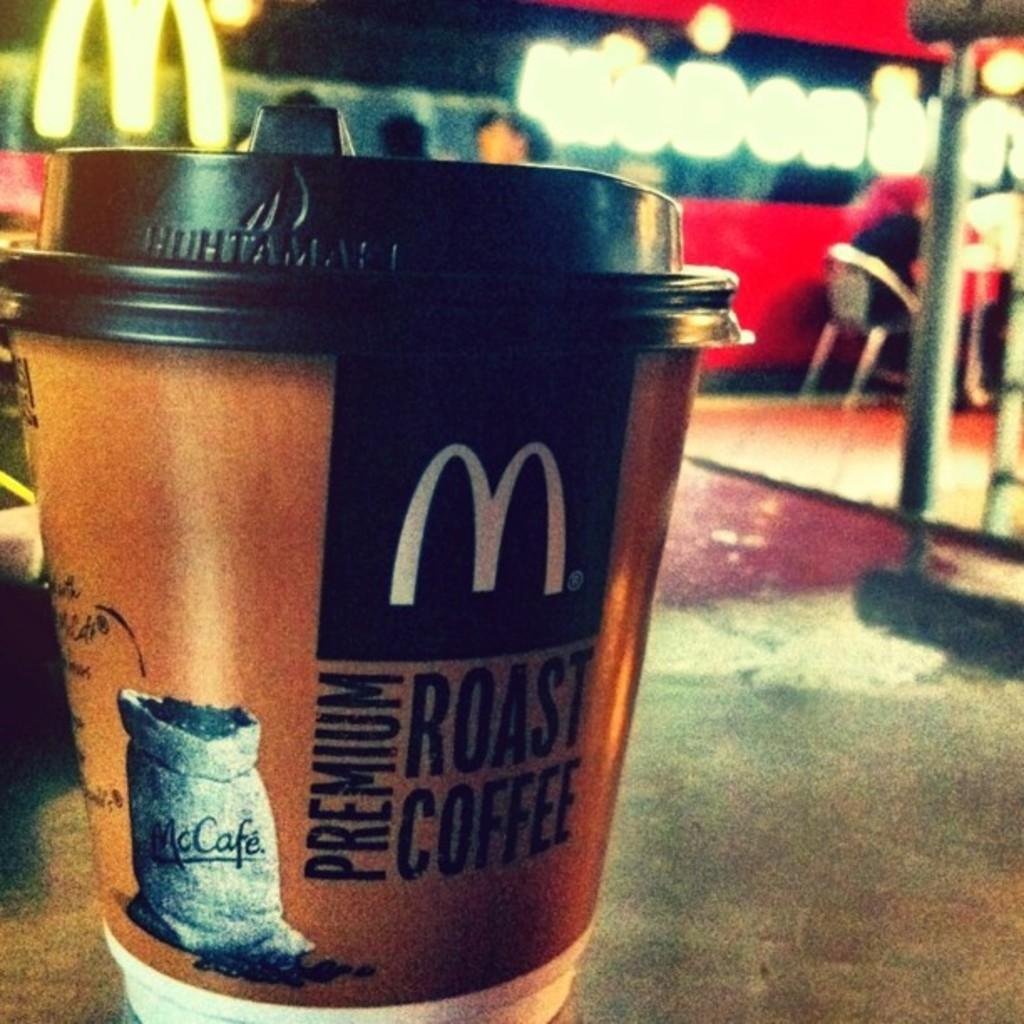What is in the cup that is visible in the image? There is text in the cup that is visible in the image. What is the person in the image doing? The person is sitting on a chair in the image. Can you describe the background of the image? The background of the image is blurred. What type of crown is the person wearing in the image? There is no crown present in the image; the person is sitting on a chair with a blurred background. How many yokes are visible in the image? There are no yokes present in the image. 